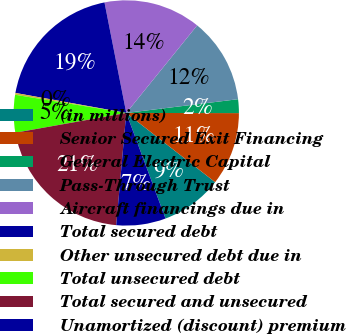Convert chart. <chart><loc_0><loc_0><loc_500><loc_500><pie_chart><fcel>(in millions)<fcel>Senior Secured Exit Financing<fcel>General Electric Capital<fcel>Pass-Through Trust<fcel>Aircraft financings due in<fcel>Total secured debt<fcel>Other unsecured debt due in<fcel>Total unsecured debt<fcel>Total secured and unsecured<fcel>Unamortized (discount) premium<nl><fcel>8.8%<fcel>10.51%<fcel>1.97%<fcel>12.22%<fcel>13.93%<fcel>19.06%<fcel>0.26%<fcel>5.39%<fcel>20.77%<fcel>7.09%<nl></chart> 